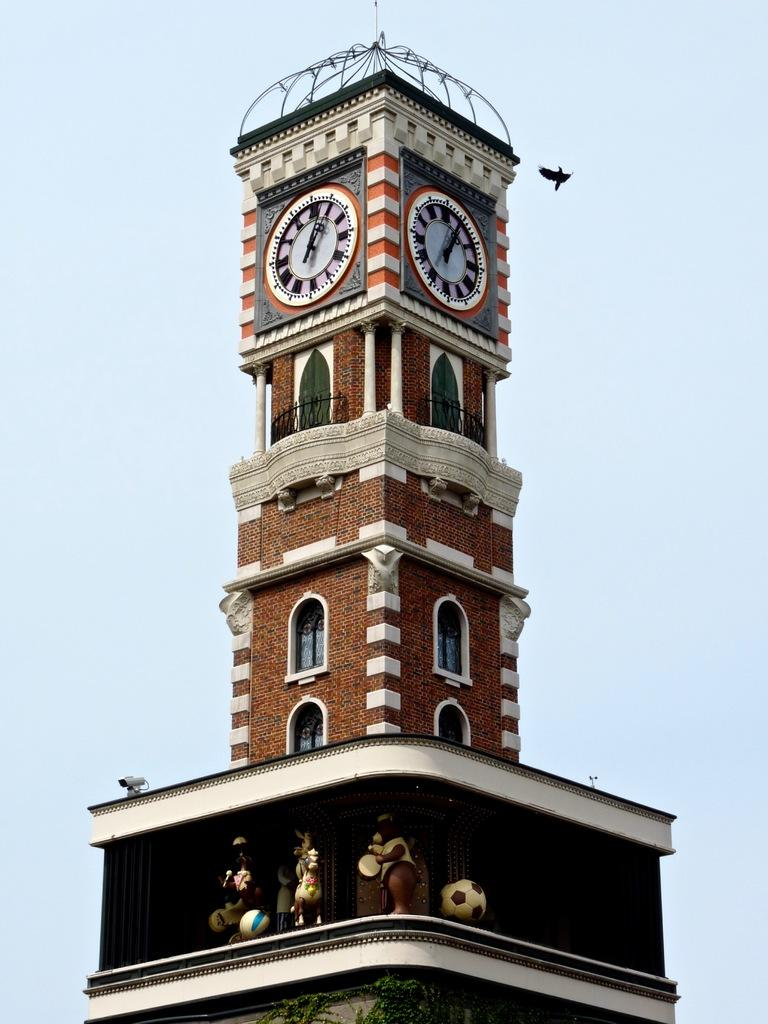What is the main structure in the picture? There is a clock tower in the picture. How many clocks are on the clock tower? The clock tower has two clocks side by side. What can be seen in the background of the picture? There is a sky visible in the background of the picture. What type of jellyfish can be seen swimming in the sky in the image? There are no jellyfish present in the image, and the sky is not a body of water where jellyfish would be found. 